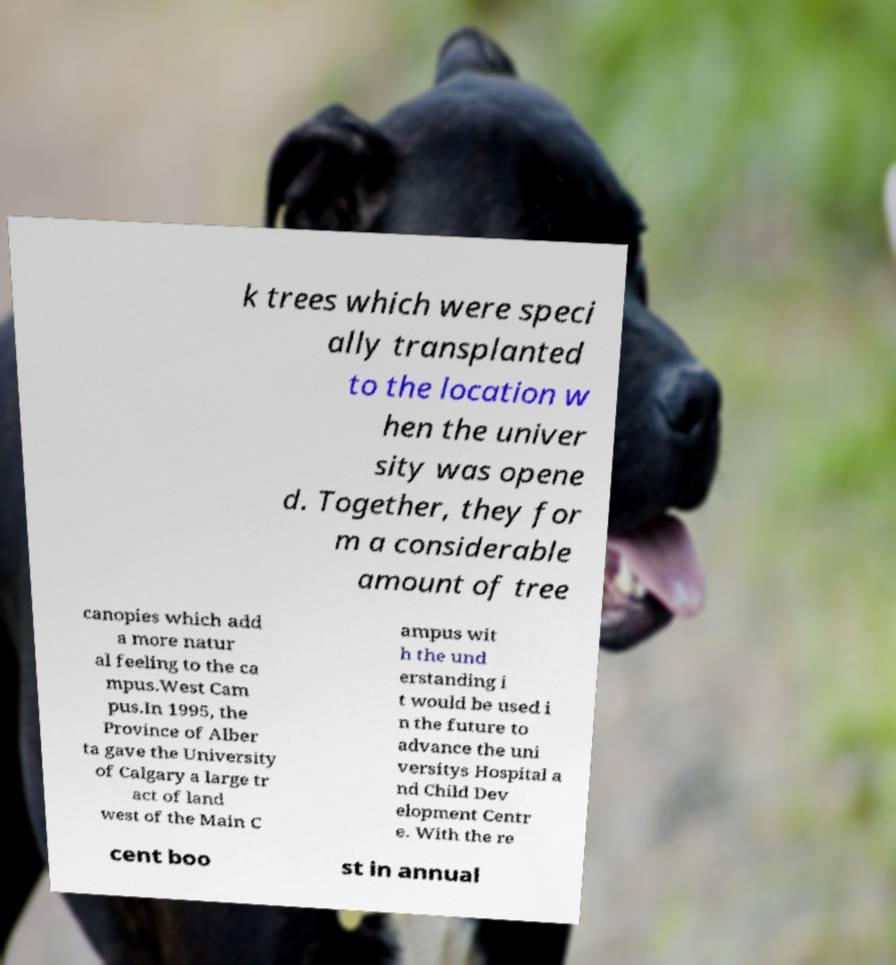I need the written content from this picture converted into text. Can you do that? k trees which were speci ally transplanted to the location w hen the univer sity was opene d. Together, they for m a considerable amount of tree canopies which add a more natur al feeling to the ca mpus.West Cam pus.In 1995, the Province of Alber ta gave the University of Calgary a large tr act of land west of the Main C ampus wit h the und erstanding i t would be used i n the future to advance the uni versitys Hospital a nd Child Dev elopment Centr e. With the re cent boo st in annual 